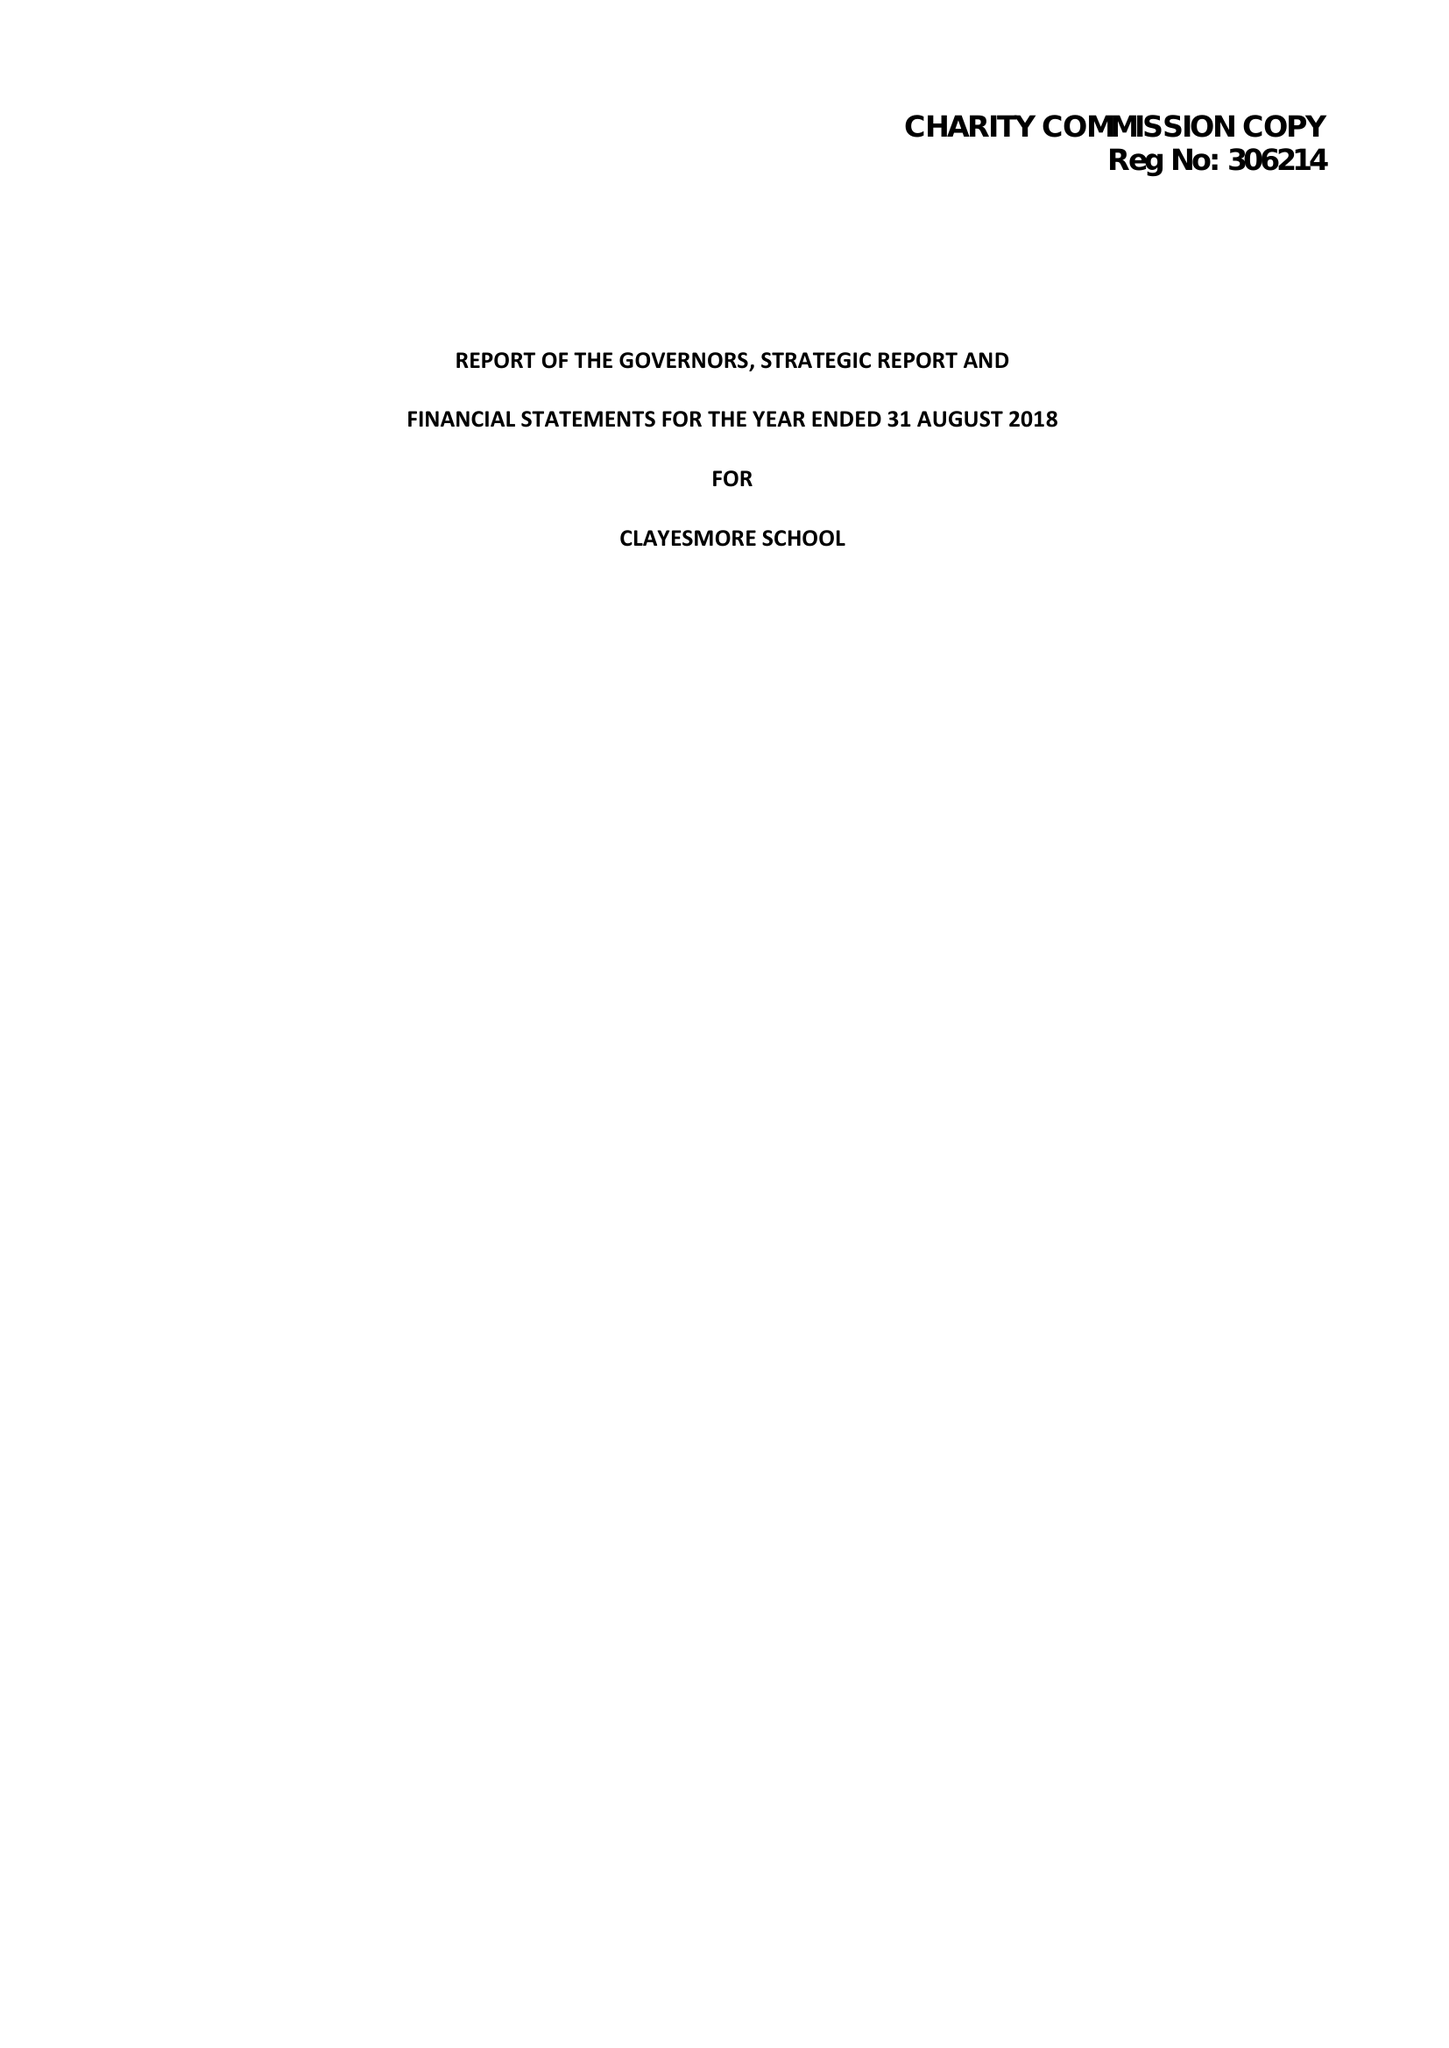What is the value for the address__post_town?
Answer the question using a single word or phrase. BLANDFORD FORUM 